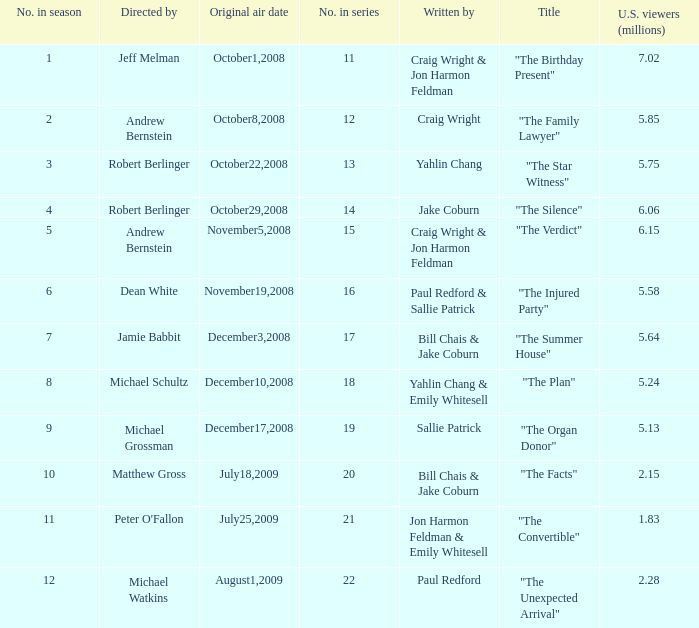What is the original air date of the episode directed by Jeff Melman? October1,2008. 